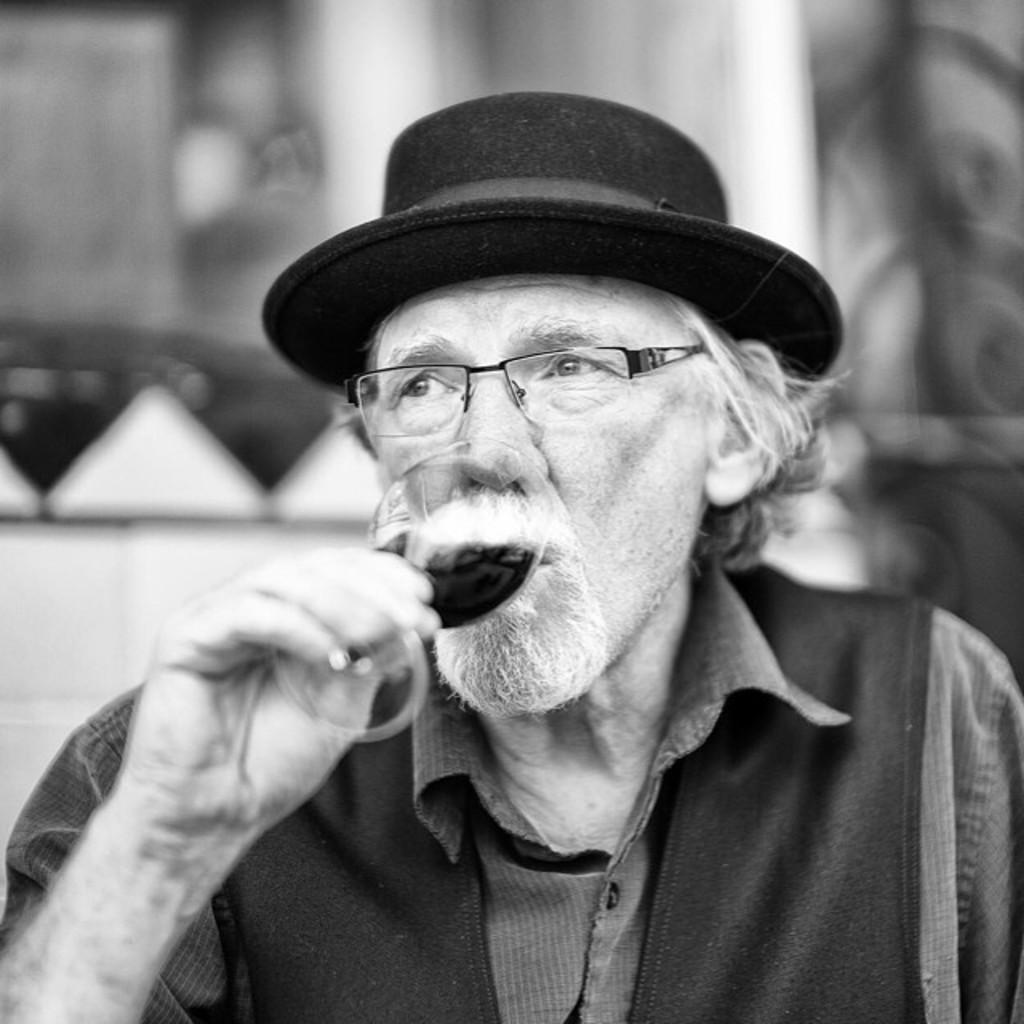Can you describe this image briefly? In this picture there is an old man in the center of the image he is wearing a hat and he is holding a glass in his hand, the background area of the image is blur. 